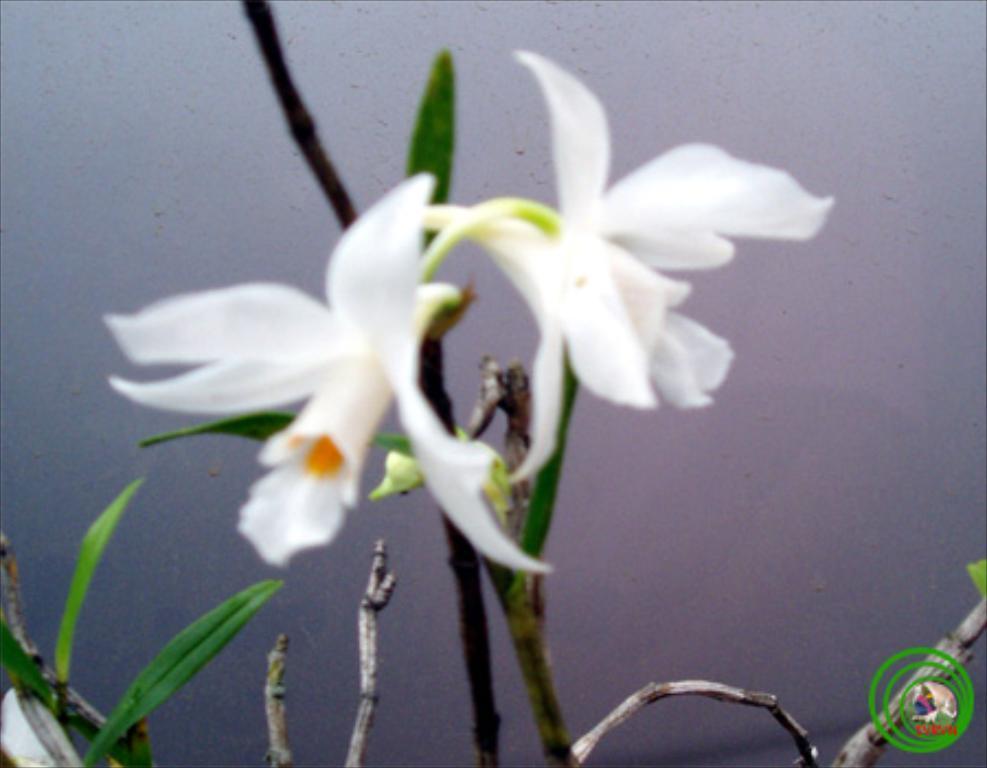How would you summarize this image in a sentence or two? In the center of the image we can see flowers of a plant. 